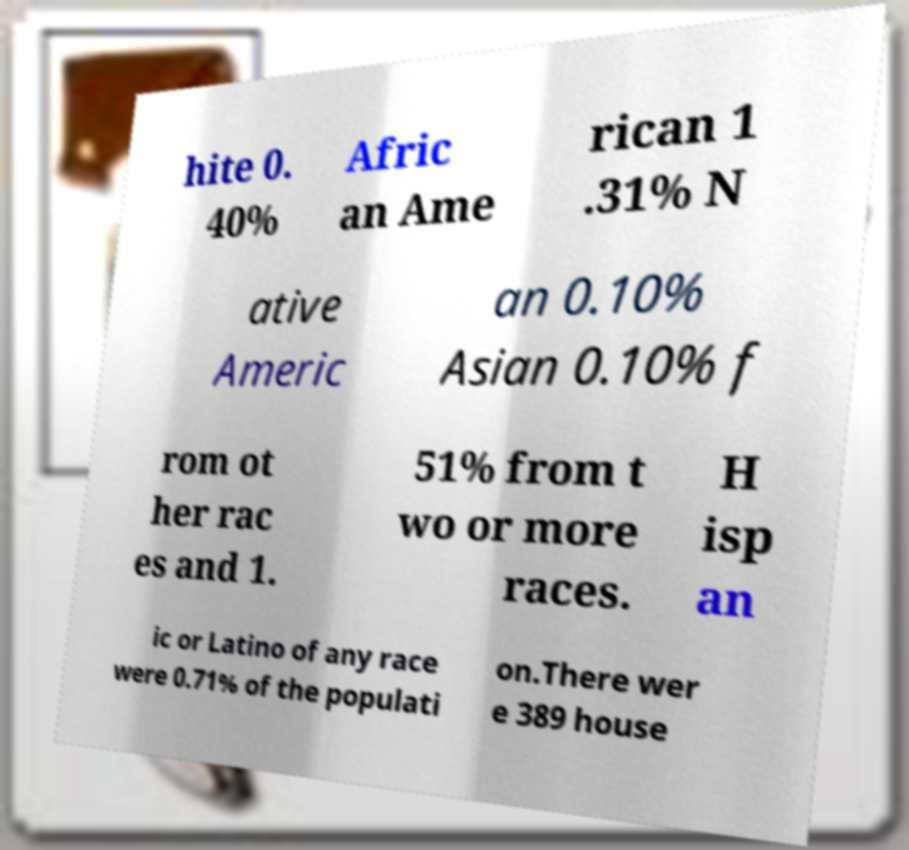What messages or text are displayed in this image? I need them in a readable, typed format. hite 0. 40% Afric an Ame rican 1 .31% N ative Americ an 0.10% Asian 0.10% f rom ot her rac es and 1. 51% from t wo or more races. H isp an ic or Latino of any race were 0.71% of the populati on.There wer e 389 house 